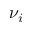Convert formula to latex. <formula><loc_0><loc_0><loc_500><loc_500>\nu _ { i }</formula> 